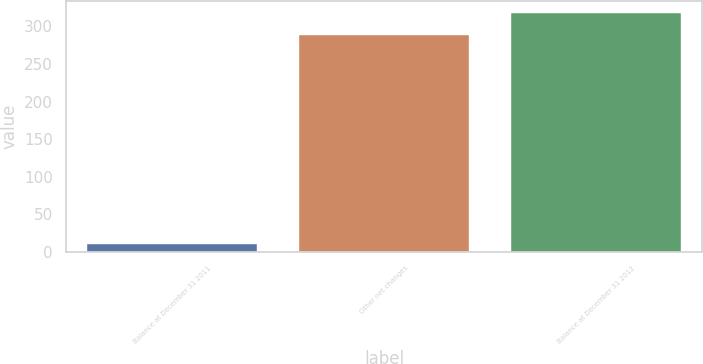Convert chart. <chart><loc_0><loc_0><loc_500><loc_500><bar_chart><fcel>Balance at December 31 2011<fcel>Other net changes<fcel>Balance at December 31 2012<nl><fcel>10<fcel>289<fcel>317.9<nl></chart> 